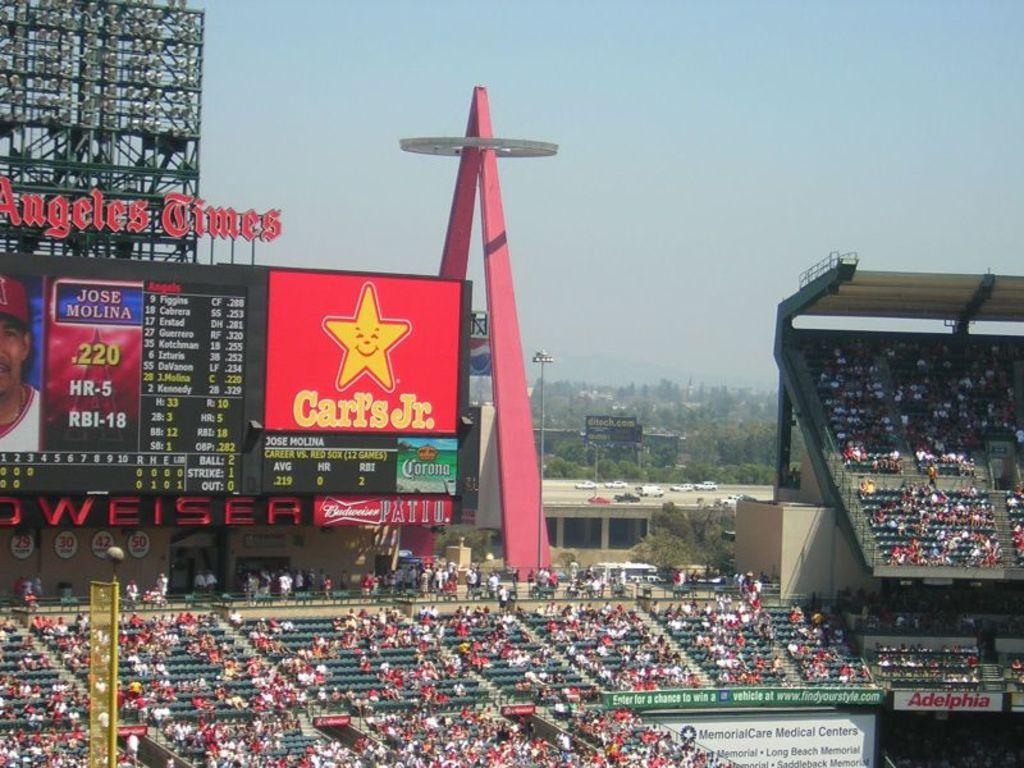<image>
Describe the image concisely. Baeball stadium with an advertisement for Carl's Jr. 